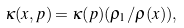<formula> <loc_0><loc_0><loc_500><loc_500>\kappa ( x , p ) = \kappa ( p ) ( \rho _ { 1 } / \rho ( x ) ) ,</formula> 